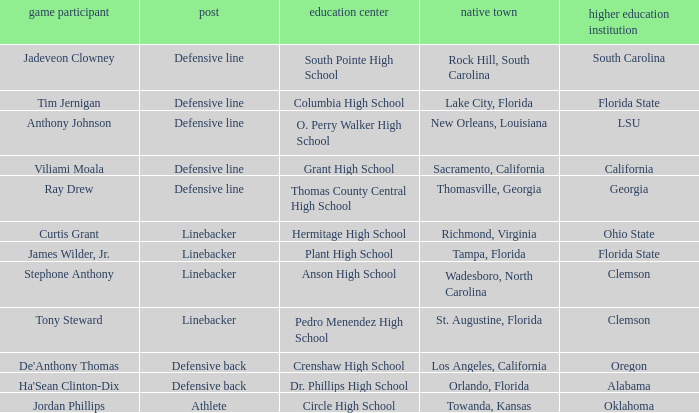What position is for Dr. Phillips high school? Defensive back. Could you parse the entire table as a dict? {'header': ['game participant', 'post', 'education center', 'native town', 'higher education institution'], 'rows': [['Jadeveon Clowney', 'Defensive line', 'South Pointe High School', 'Rock Hill, South Carolina', 'South Carolina'], ['Tim Jernigan', 'Defensive line', 'Columbia High School', 'Lake City, Florida', 'Florida State'], ['Anthony Johnson', 'Defensive line', 'O. Perry Walker High School', 'New Orleans, Louisiana', 'LSU'], ['Viliami Moala', 'Defensive line', 'Grant High School', 'Sacramento, California', 'California'], ['Ray Drew', 'Defensive line', 'Thomas County Central High School', 'Thomasville, Georgia', 'Georgia'], ['Curtis Grant', 'Linebacker', 'Hermitage High School', 'Richmond, Virginia', 'Ohio State'], ['James Wilder, Jr.', 'Linebacker', 'Plant High School', 'Tampa, Florida', 'Florida State'], ['Stephone Anthony', 'Linebacker', 'Anson High School', 'Wadesboro, North Carolina', 'Clemson'], ['Tony Steward', 'Linebacker', 'Pedro Menendez High School', 'St. Augustine, Florida', 'Clemson'], ["De'Anthony Thomas", 'Defensive back', 'Crenshaw High School', 'Los Angeles, California', 'Oregon'], ["Ha'Sean Clinton-Dix", 'Defensive back', 'Dr. Phillips High School', 'Orlando, Florida', 'Alabama'], ['Jordan Phillips', 'Athlete', 'Circle High School', 'Towanda, Kansas', 'Oklahoma']]} 